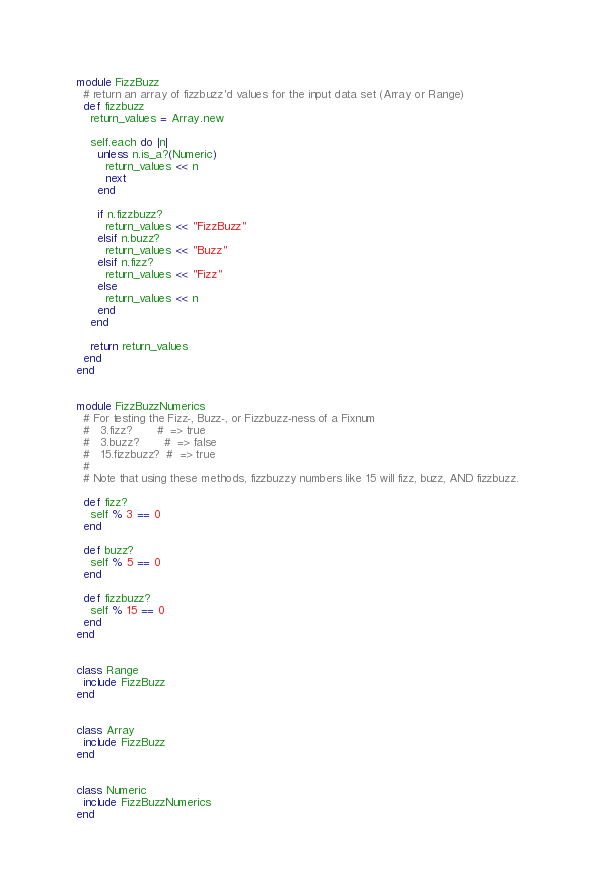<code> <loc_0><loc_0><loc_500><loc_500><_Ruby_>module FizzBuzz
  # return an array of fizzbuzz'd values for the input data set (Array or Range)
  def fizzbuzz
    return_values = Array.new

    self.each do |n|
      unless n.is_a?(Numeric)
        return_values << n
        next
      end

      if n.fizzbuzz?
        return_values << "FizzBuzz"
      elsif n.buzz?
        return_values << "Buzz"
      elsif n.fizz?
        return_values << "Fizz"
      else
        return_values << n
      end
    end

    return return_values
  end
end


module FizzBuzzNumerics
  # For testing the Fizz-, Buzz-, or Fizzbuzz-ness of a Fixnum
  #   3.fizz?       #  => true
  #   3.buzz?       #  => false
  #   15.fizzbuzz?  #  => true
  #
  # Note that using these methods, fizzbuzzy numbers like 15 will fizz, buzz, AND fizzbuzz.

  def fizz?
    self % 3 == 0
  end

  def buzz?
    self % 5 == 0
  end

  def fizzbuzz?
    self % 15 == 0
  end
end


class Range
  include FizzBuzz
end


class Array
  include FizzBuzz
end


class Numeric
  include FizzBuzzNumerics
end



</code> 